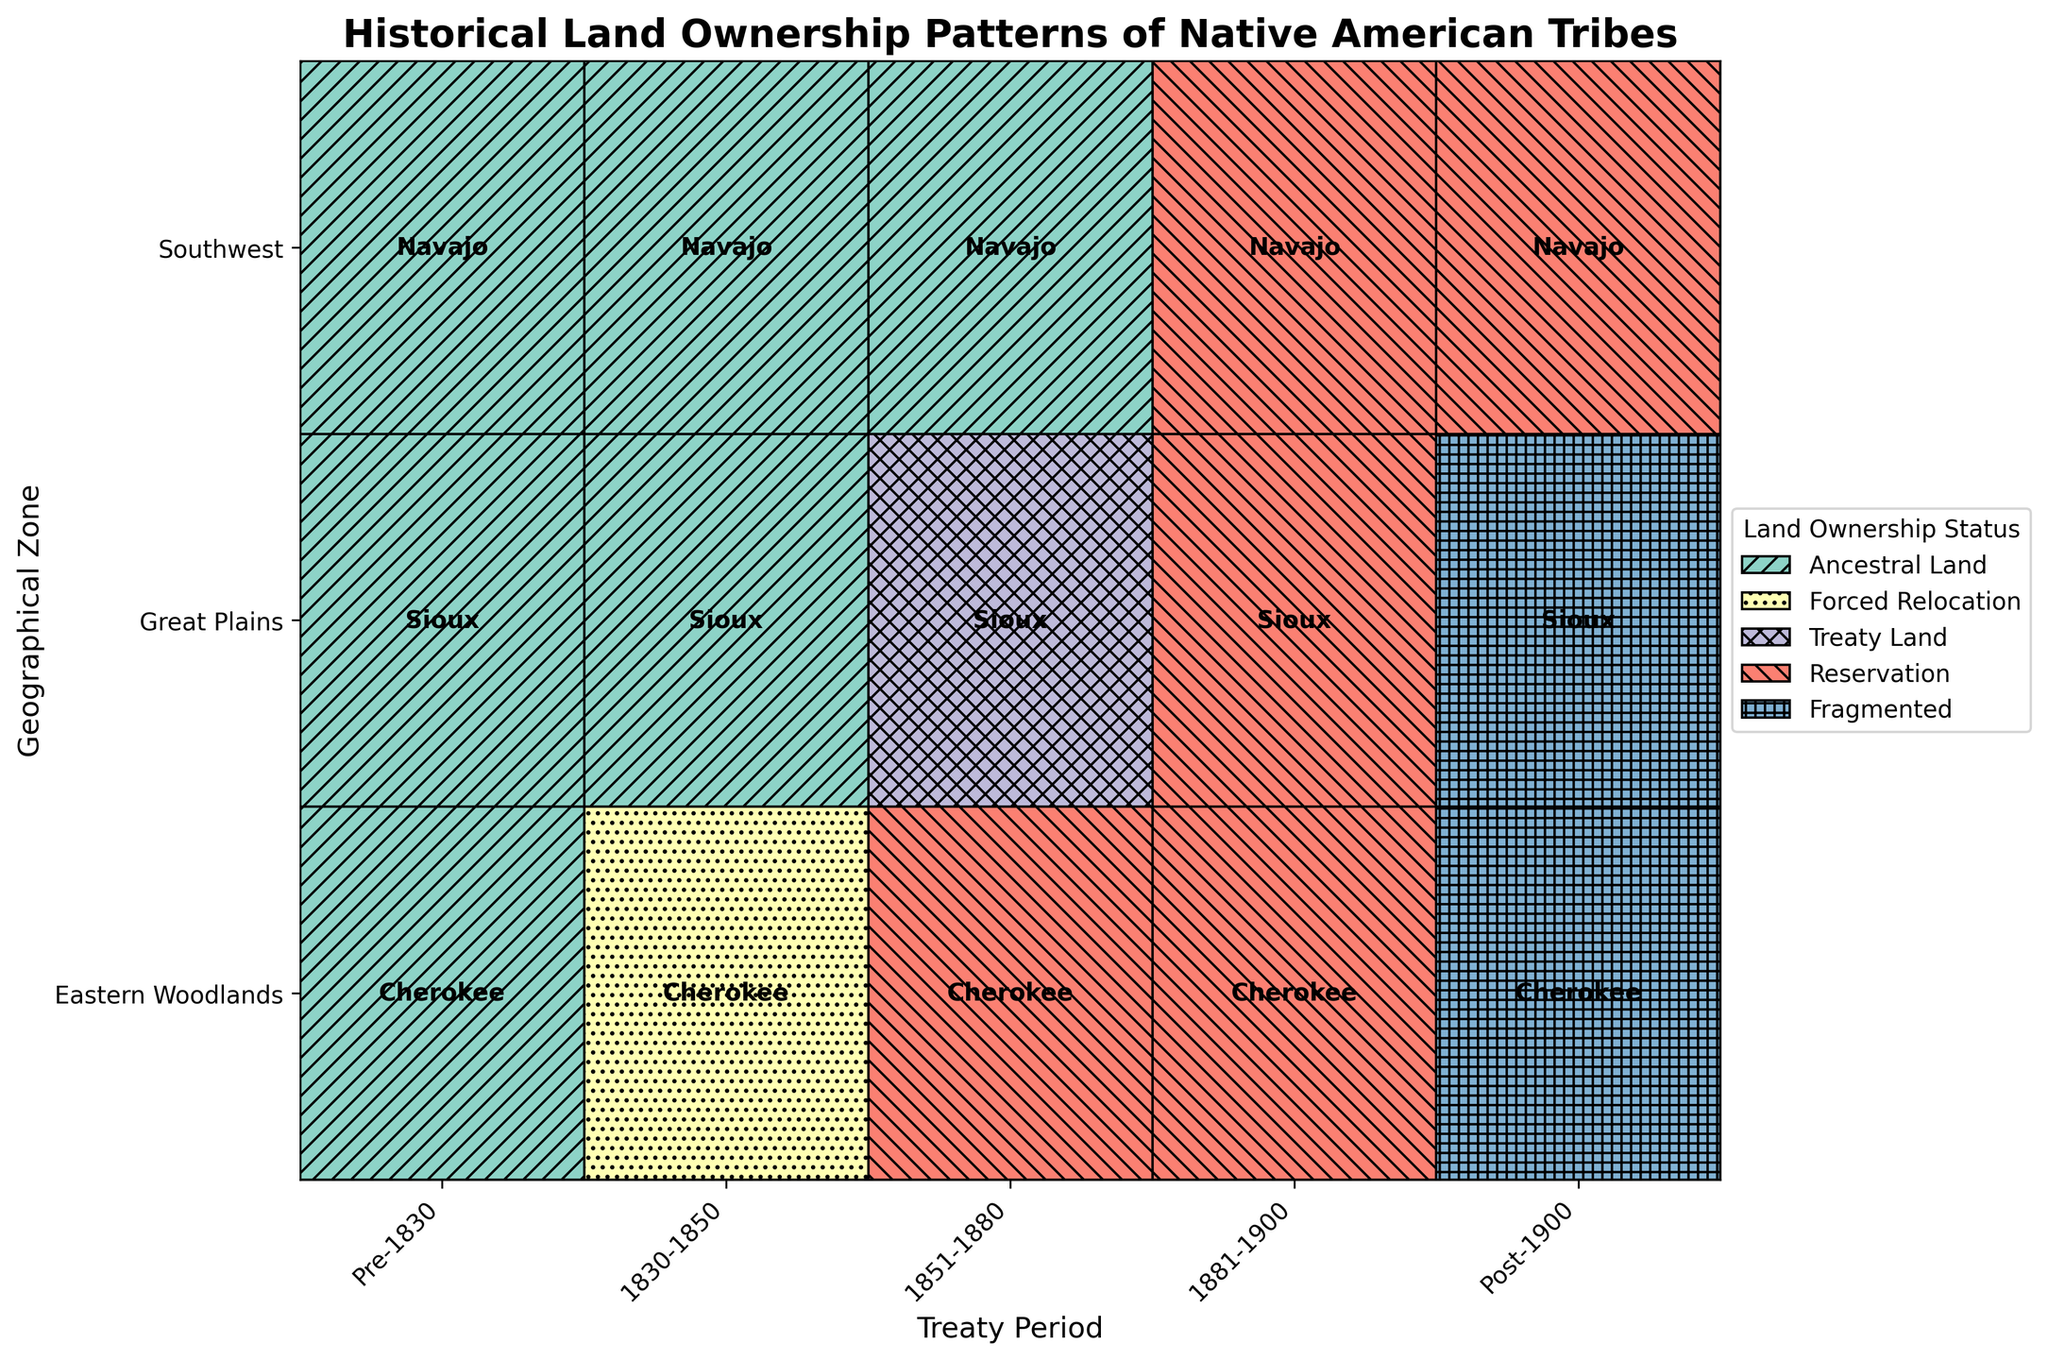What is the title of the figure? The title of a plot is usually located at the top, and it summarizes the main focus of the plot. In this case, the title reads: "Historical Land Ownership Patterns of Native American Tribes".
Answer: Historical Land Ownership Patterns of Native American Tribes Which geographical zone has the least diversity in land ownership statuses over the periods? To find this, examine the number of different land ownership statuses across all treaty periods for each geographical zone. The Eastern Woodlands and Great Plains both have four statuses, but the Southwest has only three: Ancestral Land, Reservation, and Fragmented.
Answer: Southwest How many unique land ownership statuses can be observed throughout the entire figure? The data contains five unique land ownership statuses: Ancestral Land, Forced Relocation, Treaty Land, Reservation, and Fragmented. Count these distinct categories from the legend in the figure.
Answer: 5 Was there any period where the Cherokee were in Forced Relocation? Look for the periods on the x-axis where the Cherokee in the Eastern Woodlands zone is marked with 'Forced Relocation'. This occurs during the period 1830-1850.
Answer: Yes, during 1830-1850 Which tribe retained ancestral land the longest based on the periods shown? We need to identify which tribe had 'Ancestral Land' status for the longest number of periods. The Navajo tribe in the Southwest retained ancestral lands through Pre-1830, 1830-1850, and 1851-1880, totaling three periods.
Answer: Navajo Compare the land ownership status of the Sioux tribe during the periods 1830-1850 and 1851-1880. Look at the Great Plains zone for the periods 1830-1850 and 1851-1880. In 1830-1850, the Sioux had 'Ancestral Land', while in 1851-1880 they had 'Treaty Land'.
Answer: Ancestral Land to Treaty Land In which period did the Navajo transition from ancestral land to reservation status? Identify when the land ownership status for the Navajo in the Southwest zone changes from 'Ancestral Land' to 'Reservation'. This transition occurs between the periods 1851-1880 and 1881-1900.
Answer: 1881-1900 Which land ownership status appears only once in the entire plot? Look for the land ownership status that is represented in the figure only once across all periods and zones. 'Forced Relocation' appears only once for the Cherokee in the Eastern Woodlands during 1830-1850.
Answer: Forced Relocation How did the land ownership status of the Cherokee tribe change from Pre-1830 to Post-1900? Track the changes in land ownership status for the Cherokee tribe across the periods. It changed from 'Ancestral Land'(Pre-1830) to 'Forced Relocation'(1830-1850), 'Reservation'(1851-1900), and finally to 'Fragmented'(Post-1900).
Answer: Ancestral Land to Fragmented Which periods show uniform land ownership status across all geographical zones? Find periods where each zone has the same land ownership status. In 1881-1900, all zones (Eastern Woodlands, Great Plains, Southwest) have 'Reservation' status.
Answer: 1881-1900 